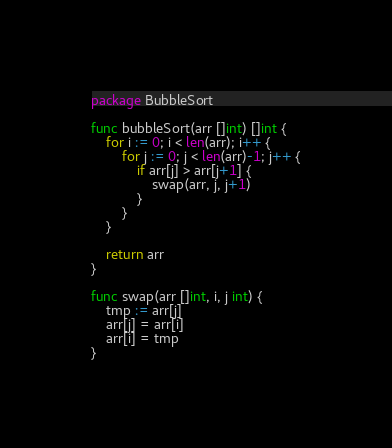Convert code to text. <code><loc_0><loc_0><loc_500><loc_500><_Go_>package BubbleSort

func bubbleSort(arr []int) []int {
	for i := 0; i < len(arr); i++ {
		for j := 0; j < len(arr)-1; j++ {
			if arr[j] > arr[j+1] {
				swap(arr, j, j+1)
			}
		}
	}

	return arr
}

func swap(arr []int, i, j int) {
	tmp := arr[j]
	arr[j] = arr[i]
	arr[i] = tmp
}
</code> 